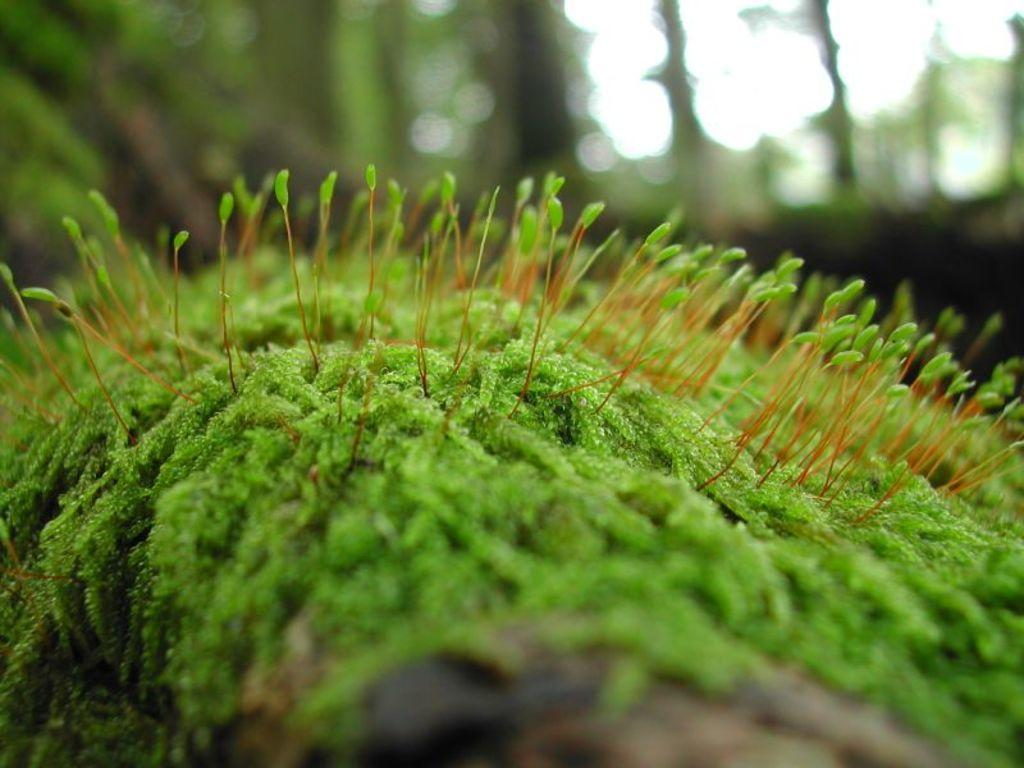What type of vegetation is present on the ground in the image? There is grass on the ground in the image. Are there any other plants visible in the image? Yes, there are small plants in the image. Can you describe the background of the image? The background of the image is blurry. What type of rhythm can be heard in the image? There is no sound or rhythm present in the image, as it is a still photograph. 